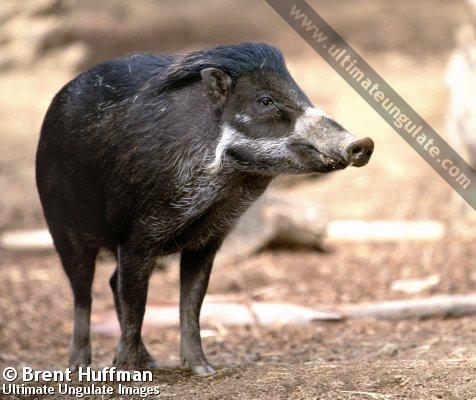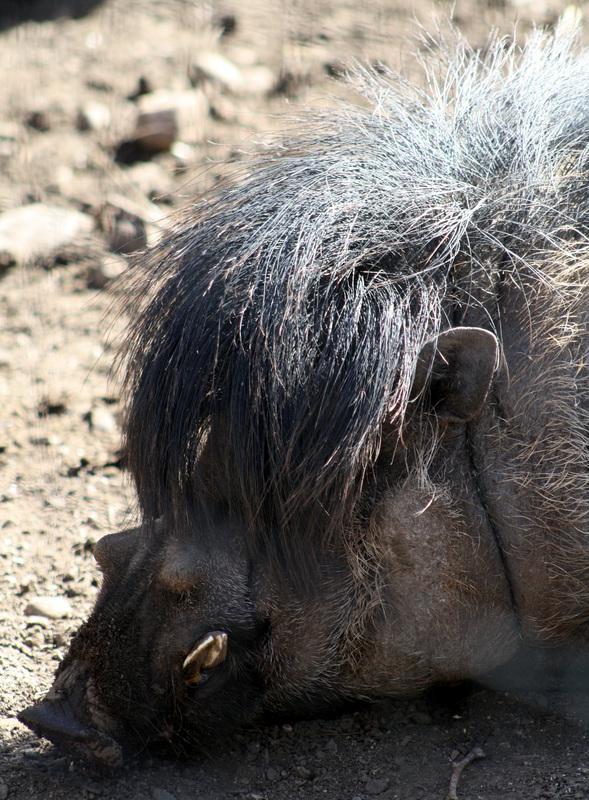The first image is the image on the left, the second image is the image on the right. Considering the images on both sides, is "There is one mammal facing to the side, and one mammal facing the camera." valid? Answer yes or no. No. The first image is the image on the left, the second image is the image on the right. Examine the images to the left and right. Is the description "At least one pig has its snout on the ground." accurate? Answer yes or no. Yes. 